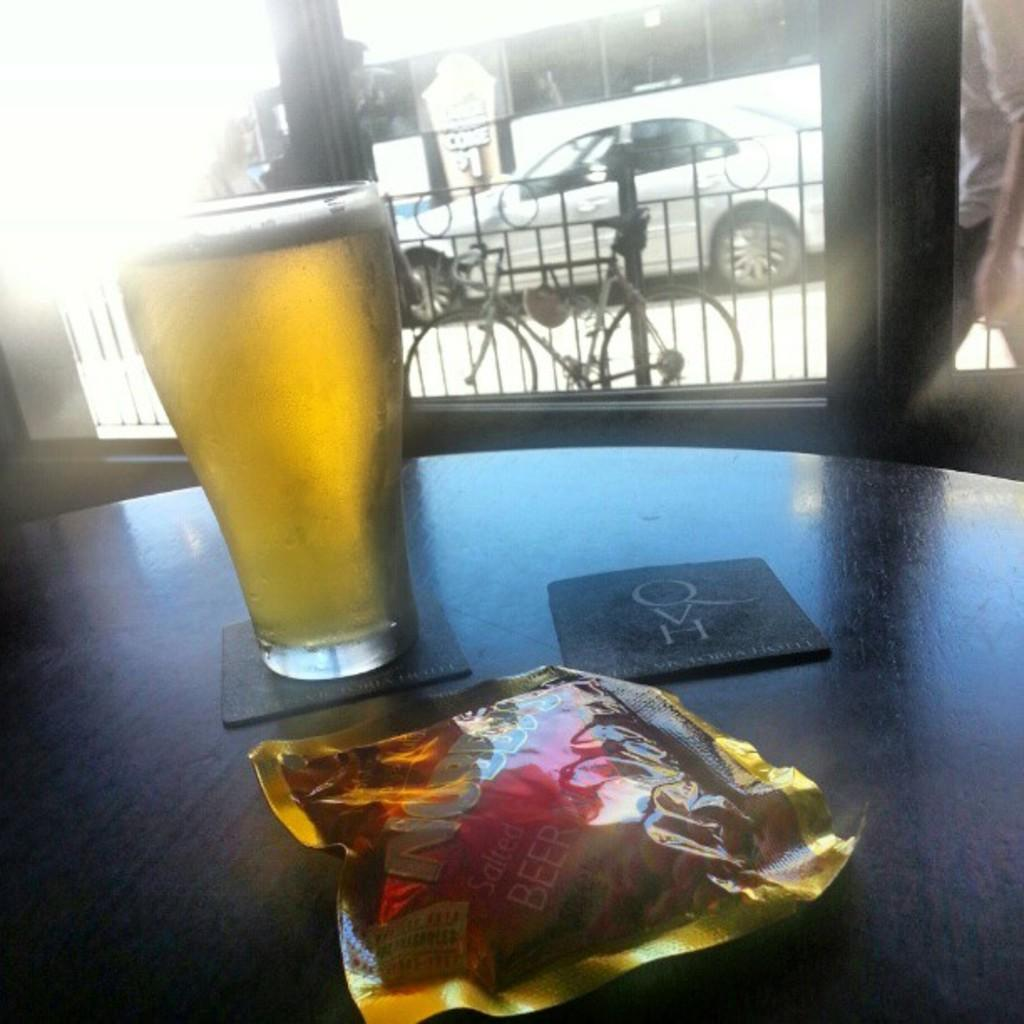What is on the table in the image? There is a glass of wine and a packet on the table. What is the location of the table in relation to the glass door? The table is located near a glass door. What can be seen through the glass door? Two people and a bicycle at the fence are visible through the glass door. What is happening on the road outside? Vehicles are visible on the road through the glass door. What type of spark can be seen coming from the horn of the bicycle in the image? There is no spark or horn present on the bicycle in the image. What territory is being claimed by the people visible through the glass door? There is no indication of territory being claimed by the people visible through the glass door in the image. 